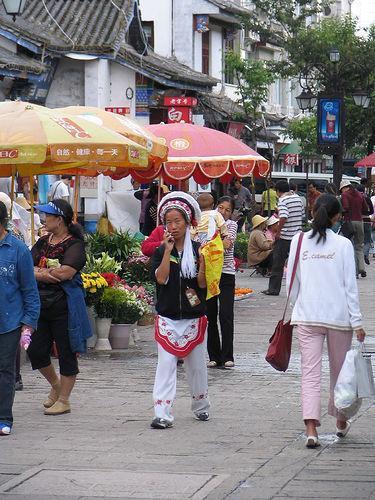How many umbrellas are there?
Give a very brief answer. 3. How many people are in the picture?
Give a very brief answer. 6. How many us airways express airplanes are in this image?
Give a very brief answer. 0. 